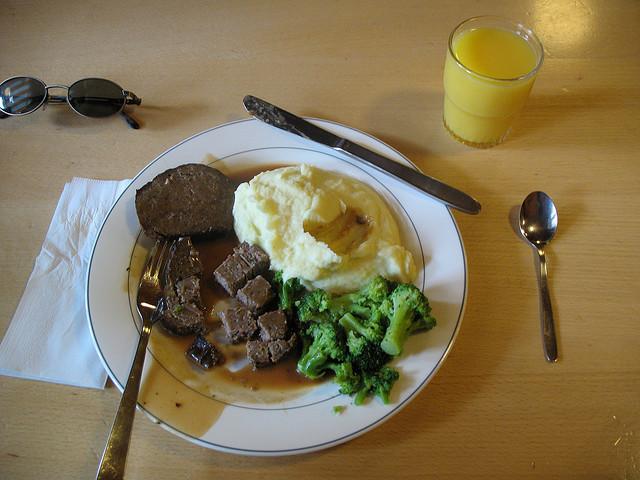Is the knife placed on the right?
Be succinct. Yes. Is the glass full?
Give a very brief answer. Yes. Is the spoon real silver?
Short answer required. No. Is the beverage cold?
Answer briefly. Yes. What is the green vegetable on the plate?
Give a very brief answer. Broccoli. What is the big piece of meat in the middle?
Be succinct. Steak. Are there any meats?
Concise answer only. Yes. Are the glasses full?
Give a very brief answer. Yes. Which meal of the day is this?
Quick response, please. Dinner. How many forks are there?
Be succinct. 1. What color is the spoon?
Answer briefly. Silver. How many spoons are present?
Be succinct. 1. What food is shown?
Short answer required. Dinner. Does this meal consist of meat?
Write a very short answer. Yes. What is the brown stuff all over the food called?
Write a very short answer. Gravy. What kind of meat is on the plate?
Quick response, please. Beef. Is the meal partially eaten?
Short answer required. Yes. How many spoons are there?
Keep it brief. 1. What kind of food is shown?
Concise answer only. Dinner. Which item does not belong in a soup?
Quick response, please. Orange juice. What liquid is in the glass closest to the plate?
Short answer required. Orange juice. 